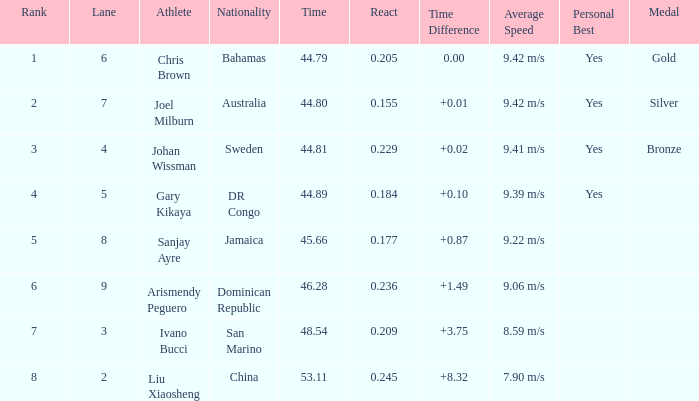How many total Rank listings have Liu Xiaosheng listed as the athlete with a react entry that is smaller than 0.245? 0.0. 